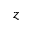<formula> <loc_0><loc_0><loc_500><loc_500>z</formula> 